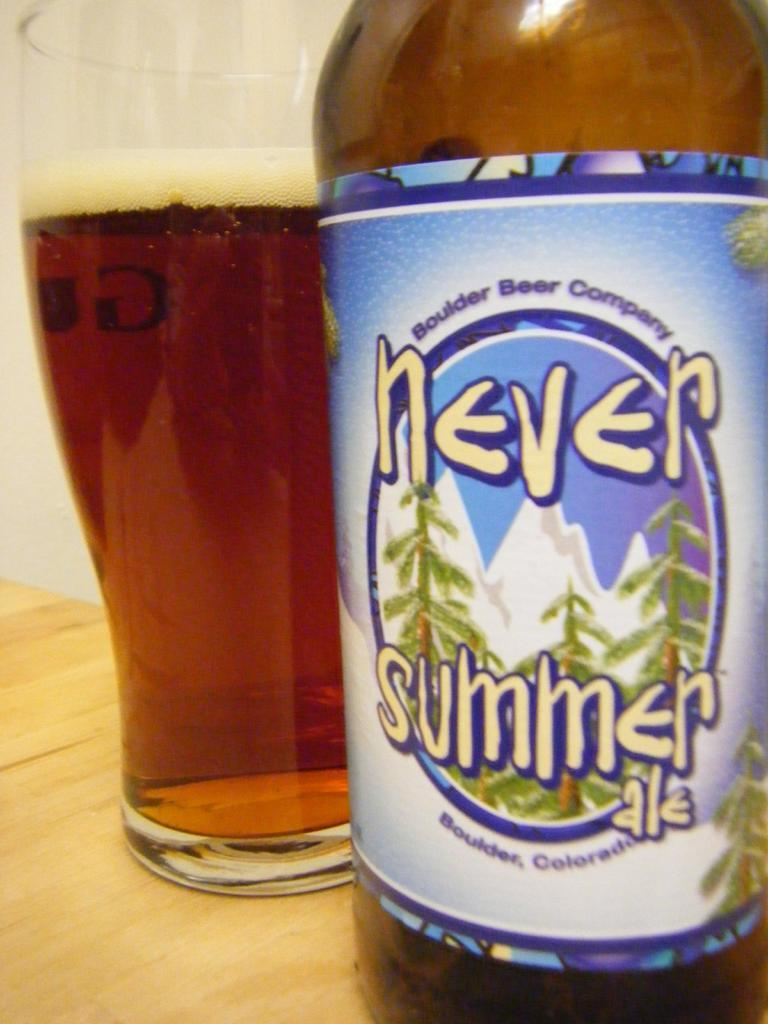<image>
Offer a succinct explanation of the picture presented. A glass of beer pored from Never Summer Ale. 